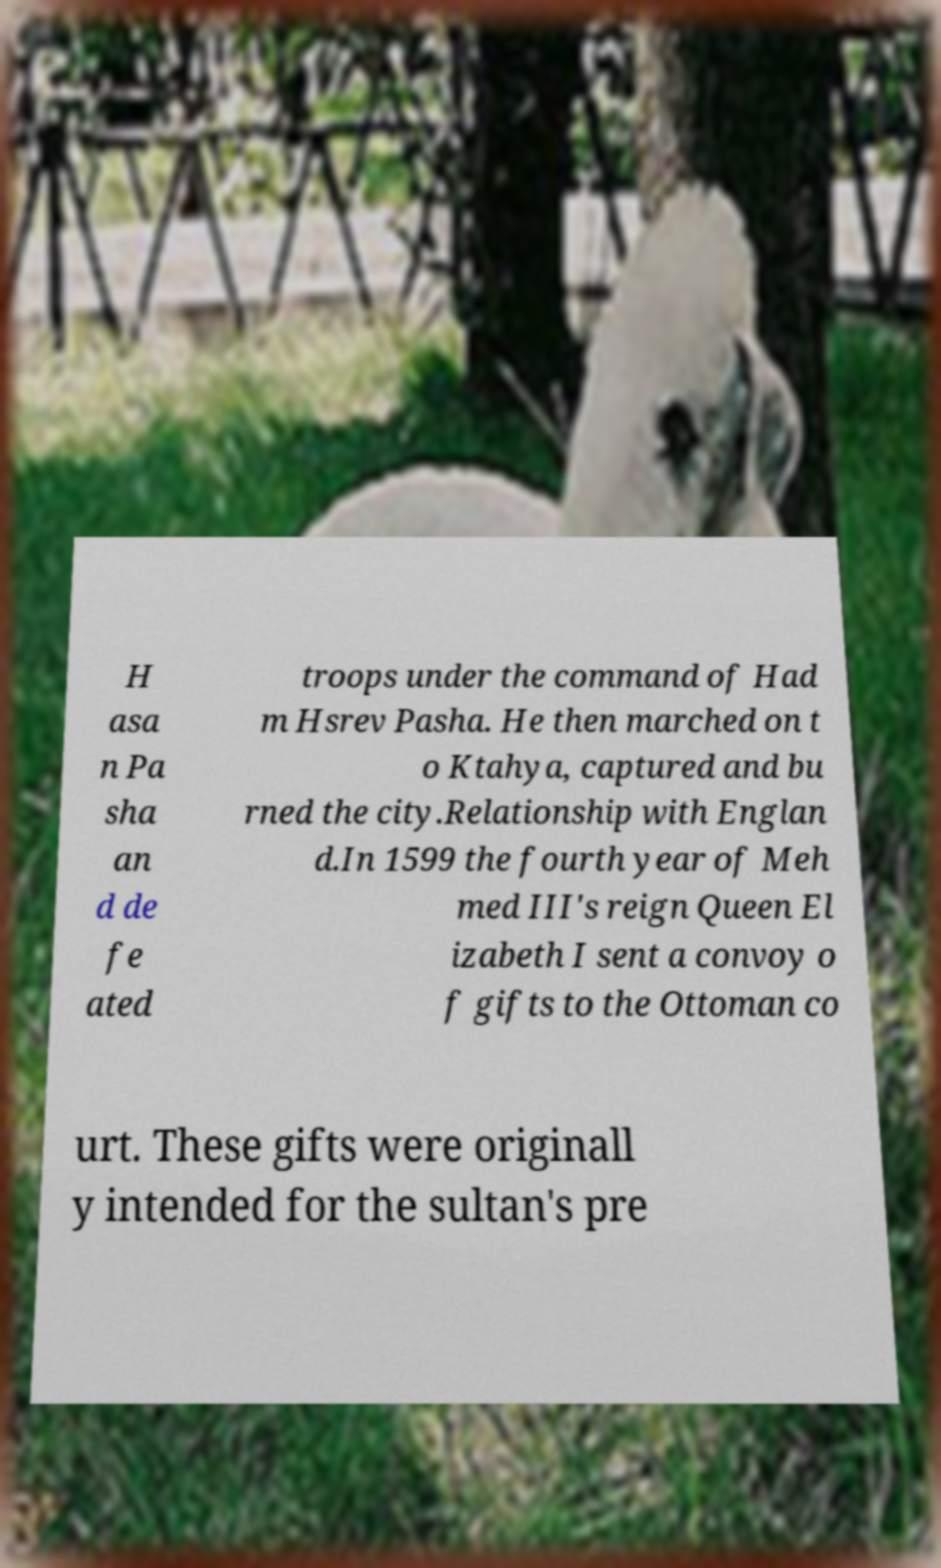Can you accurately transcribe the text from the provided image for me? H asa n Pa sha an d de fe ated troops under the command of Had m Hsrev Pasha. He then marched on t o Ktahya, captured and bu rned the city.Relationship with Englan d.In 1599 the fourth year of Meh med III's reign Queen El izabeth I sent a convoy o f gifts to the Ottoman co urt. These gifts were originall y intended for the sultan's pre 